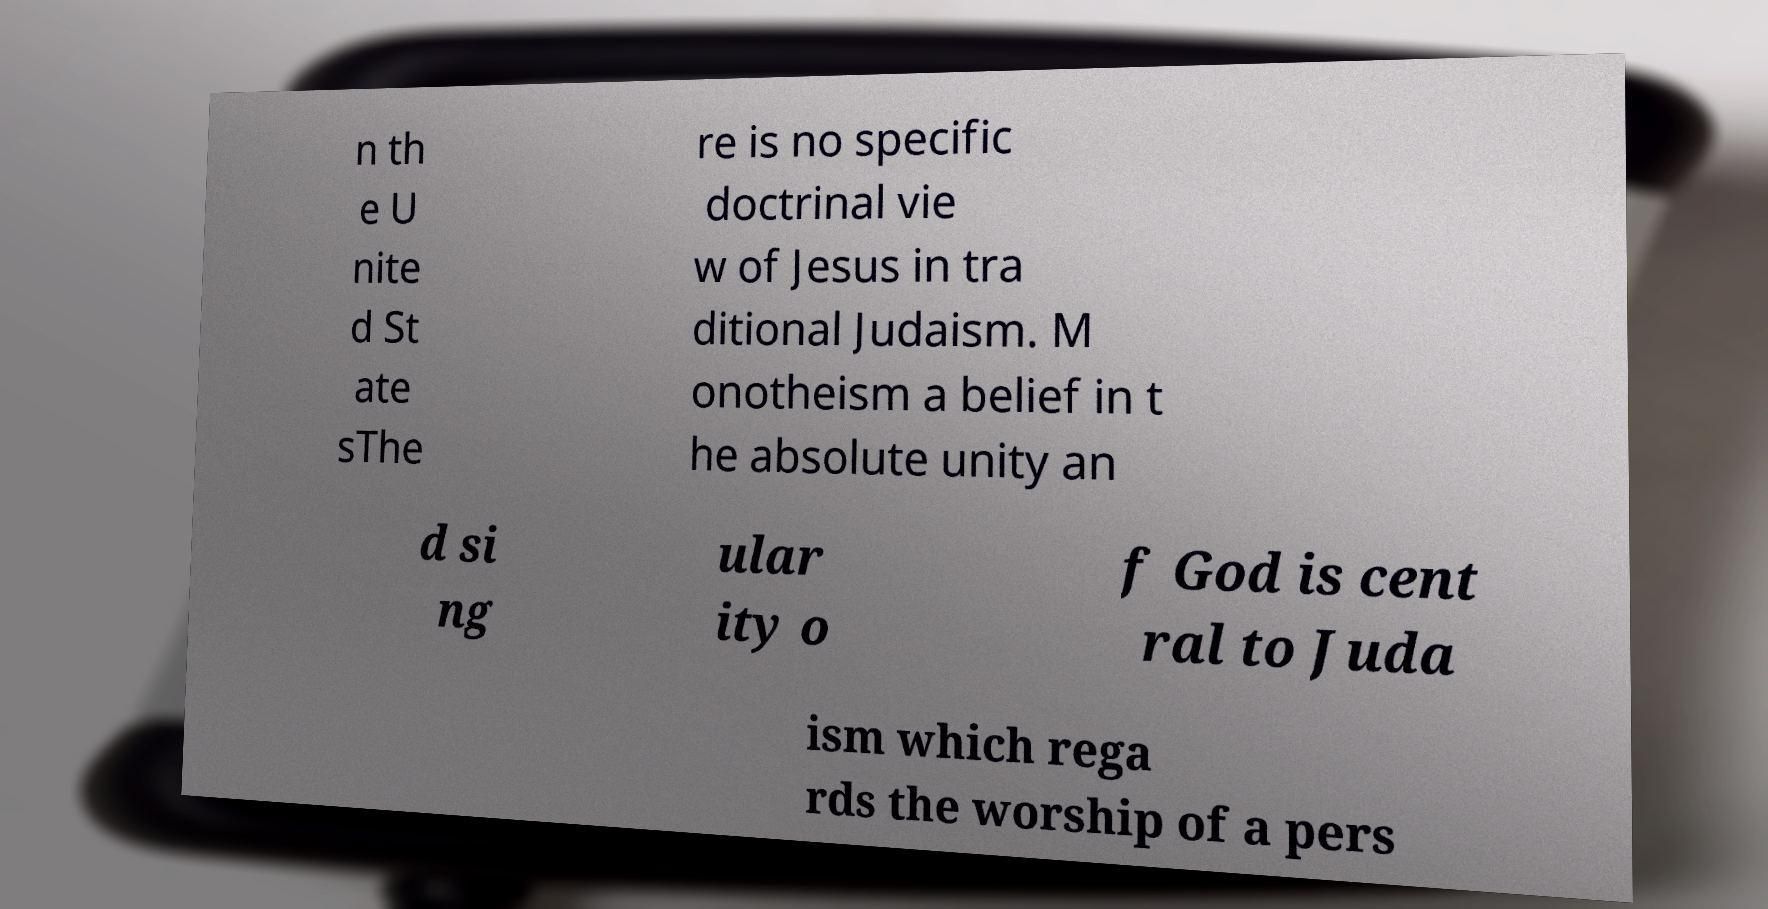What messages or text are displayed in this image? I need them in a readable, typed format. n th e U nite d St ate sThe re is no specific doctrinal vie w of Jesus in tra ditional Judaism. M onotheism a belief in t he absolute unity an d si ng ular ity o f God is cent ral to Juda ism which rega rds the worship of a pers 